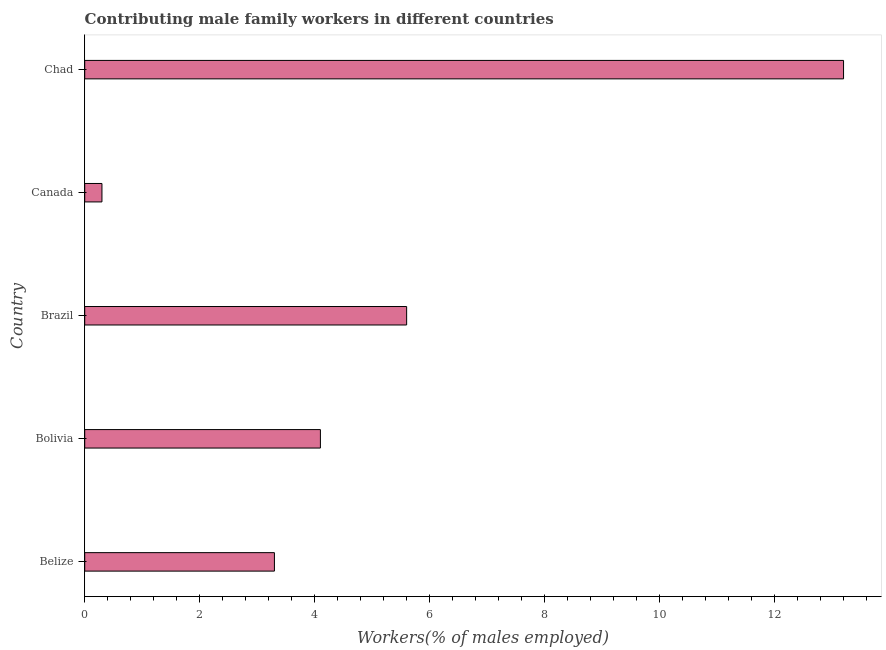What is the title of the graph?
Your answer should be compact. Contributing male family workers in different countries. What is the label or title of the X-axis?
Offer a terse response. Workers(% of males employed). What is the contributing male family workers in Canada?
Offer a very short reply. 0.3. Across all countries, what is the maximum contributing male family workers?
Keep it short and to the point. 13.2. Across all countries, what is the minimum contributing male family workers?
Your answer should be compact. 0.3. In which country was the contributing male family workers maximum?
Your answer should be very brief. Chad. What is the sum of the contributing male family workers?
Offer a very short reply. 26.5. What is the difference between the contributing male family workers in Bolivia and Brazil?
Make the answer very short. -1.5. What is the average contributing male family workers per country?
Your answer should be very brief. 5.3. What is the median contributing male family workers?
Ensure brevity in your answer.  4.1. In how many countries, is the contributing male family workers greater than 13.2 %?
Ensure brevity in your answer.  0. What is the ratio of the contributing male family workers in Belize to that in Bolivia?
Provide a succinct answer. 0.81. Is the difference between the contributing male family workers in Belize and Canada greater than the difference between any two countries?
Keep it short and to the point. No. Is the sum of the contributing male family workers in Bolivia and Brazil greater than the maximum contributing male family workers across all countries?
Ensure brevity in your answer.  No. What is the difference between the highest and the lowest contributing male family workers?
Your answer should be compact. 12.9. In how many countries, is the contributing male family workers greater than the average contributing male family workers taken over all countries?
Provide a short and direct response. 2. How many bars are there?
Keep it short and to the point. 5. Are all the bars in the graph horizontal?
Offer a very short reply. Yes. How many countries are there in the graph?
Your response must be concise. 5. What is the Workers(% of males employed) of Belize?
Your answer should be very brief. 3.3. What is the Workers(% of males employed) of Bolivia?
Offer a very short reply. 4.1. What is the Workers(% of males employed) of Brazil?
Your answer should be very brief. 5.6. What is the Workers(% of males employed) of Canada?
Provide a succinct answer. 0.3. What is the Workers(% of males employed) of Chad?
Give a very brief answer. 13.2. What is the difference between the Workers(% of males employed) in Belize and Bolivia?
Keep it short and to the point. -0.8. What is the difference between the Workers(% of males employed) in Bolivia and Brazil?
Keep it short and to the point. -1.5. What is the difference between the Workers(% of males employed) in Bolivia and Canada?
Ensure brevity in your answer.  3.8. What is the difference between the Workers(% of males employed) in Canada and Chad?
Your answer should be compact. -12.9. What is the ratio of the Workers(% of males employed) in Belize to that in Bolivia?
Keep it short and to the point. 0.81. What is the ratio of the Workers(% of males employed) in Belize to that in Brazil?
Offer a terse response. 0.59. What is the ratio of the Workers(% of males employed) in Bolivia to that in Brazil?
Your answer should be very brief. 0.73. What is the ratio of the Workers(% of males employed) in Bolivia to that in Canada?
Your answer should be compact. 13.67. What is the ratio of the Workers(% of males employed) in Bolivia to that in Chad?
Give a very brief answer. 0.31. What is the ratio of the Workers(% of males employed) in Brazil to that in Canada?
Make the answer very short. 18.67. What is the ratio of the Workers(% of males employed) in Brazil to that in Chad?
Offer a very short reply. 0.42. What is the ratio of the Workers(% of males employed) in Canada to that in Chad?
Offer a terse response. 0.02. 